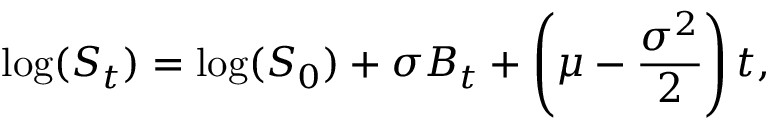Convert formula to latex. <formula><loc_0><loc_0><loc_500><loc_500>\log ( S _ { t } ) = \log ( S _ { 0 } ) + \sigma B _ { t } + \left ( \mu - { \frac { \sigma ^ { 2 } } { 2 } } \right ) t ,</formula> 